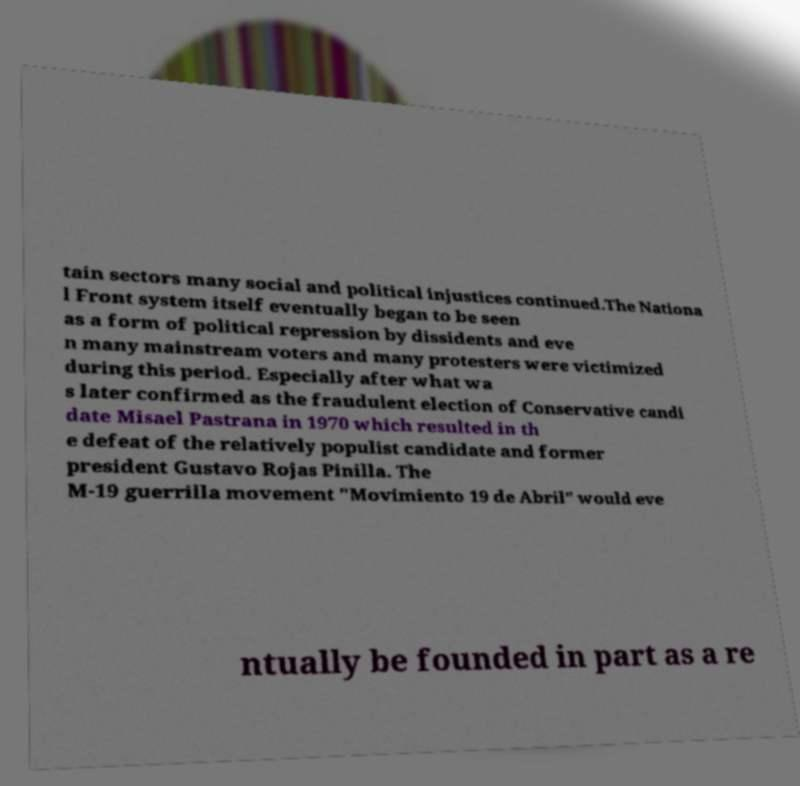Please read and relay the text visible in this image. What does it say? tain sectors many social and political injustices continued.The Nationa l Front system itself eventually began to be seen as a form of political repression by dissidents and eve n many mainstream voters and many protesters were victimized during this period. Especially after what wa s later confirmed as the fraudulent election of Conservative candi date Misael Pastrana in 1970 which resulted in th e defeat of the relatively populist candidate and former president Gustavo Rojas Pinilla. The M-19 guerrilla movement "Movimiento 19 de Abril" would eve ntually be founded in part as a re 